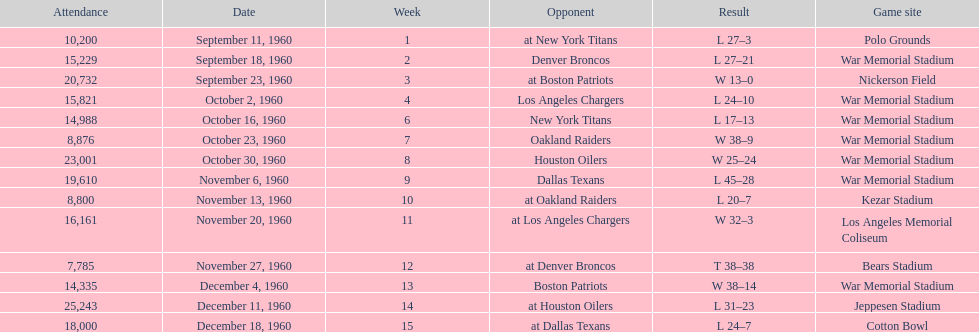How many games had an attendance of 10,000 at most? 11. 